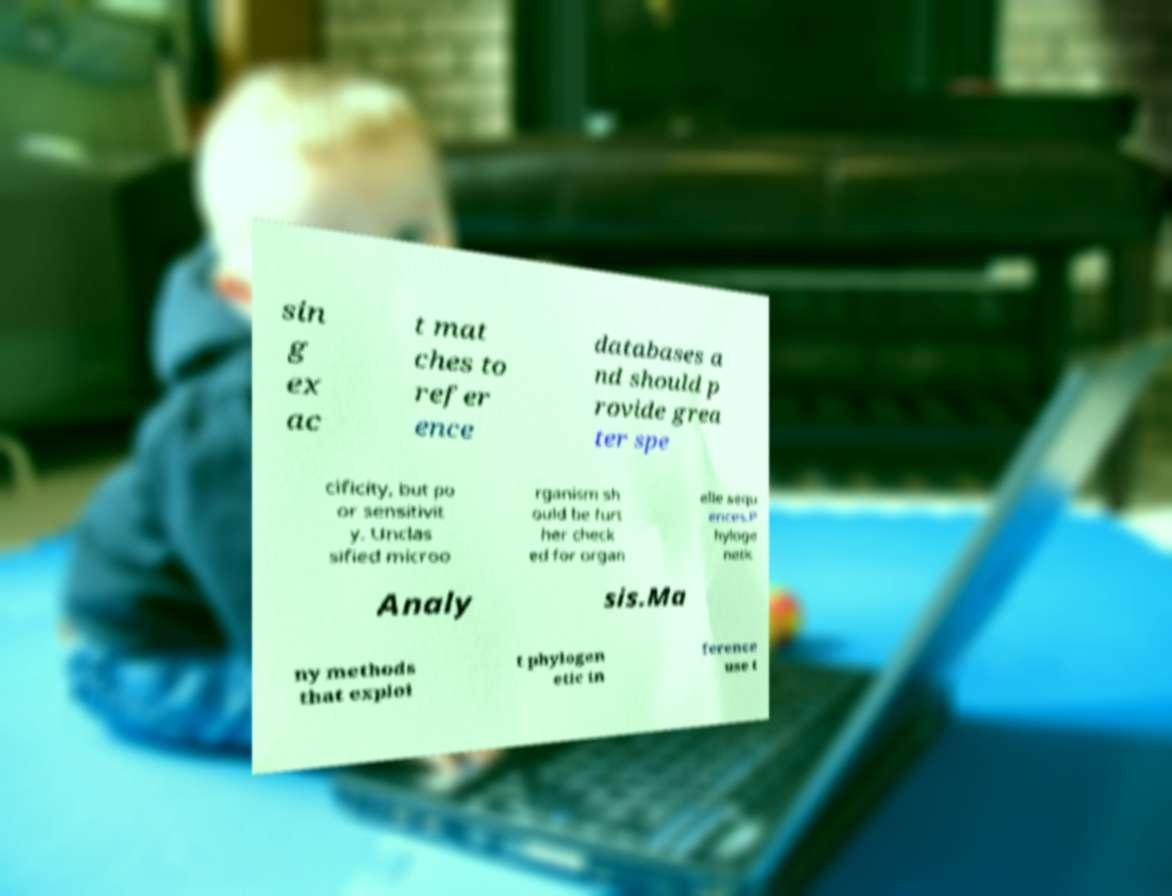Can you read and provide the text displayed in the image?This photo seems to have some interesting text. Can you extract and type it out for me? sin g ex ac t mat ches to refer ence databases a nd should p rovide grea ter spe cificity, but po or sensitivit y. Unclas sified microo rganism sh ould be furt her check ed for organ elle sequ ences.P hyloge netic Analy sis.Ma ny methods that exploi t phylogen etic in ference use t 